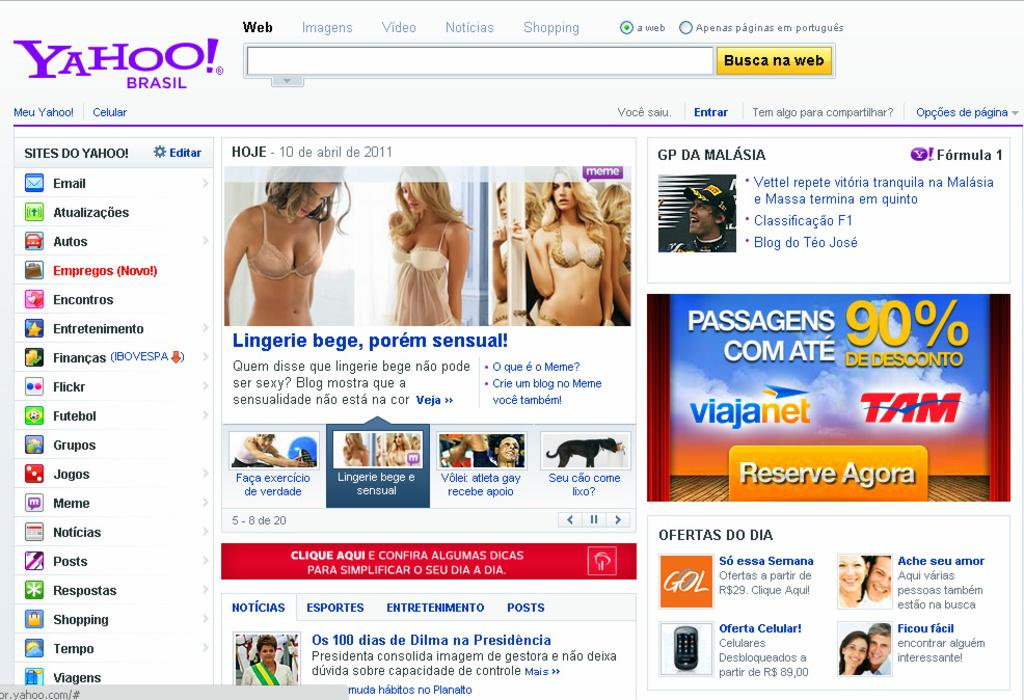What type of content is displayed in the image? The image contains a web page. What can be seen in the photos on the web page? There are photos of people on the web page. What other elements are present on the web page besides photos? There are logos and text written on the web page. Can you see a baby driving a rock in the image? No, there is no baby driving a rock in the image. The image contains a web page with photos of people, logos, and text. 